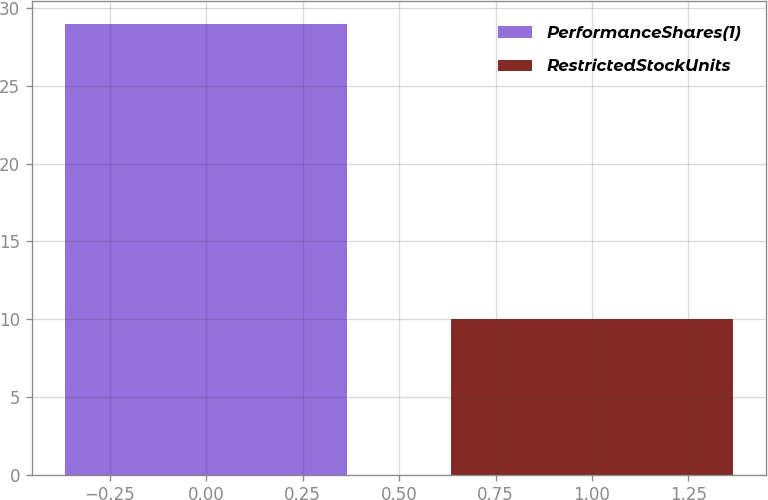Convert chart. <chart><loc_0><loc_0><loc_500><loc_500><bar_chart><fcel>PerformanceShares(1)<fcel>RestrictedStockUnits<nl><fcel>29<fcel>10<nl></chart> 